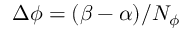Convert formula to latex. <formula><loc_0><loc_0><loc_500><loc_500>\Delta \phi = ( \beta - \alpha ) / N _ { \phi }</formula> 